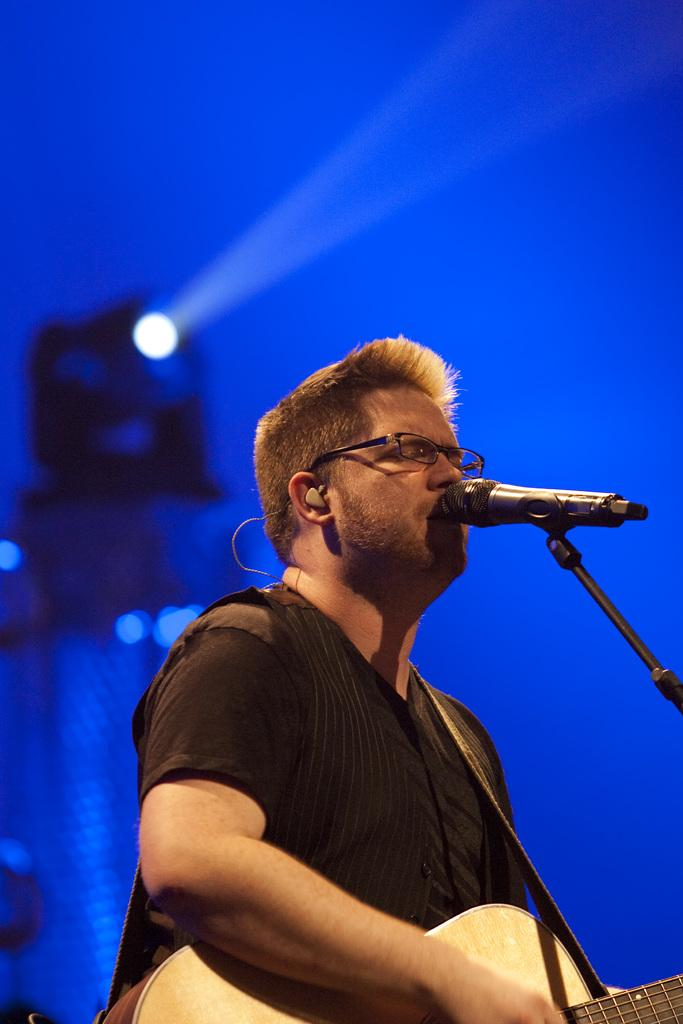What is the man in the image doing? The man is singing a song. What instrument is the man holding in the image? The man is holding a guitar. What device is present for amplifying the man's voice? There is a microphone in the image. How is the microphone positioned in the image? The microphone is on a microphone stand in the image. What is the color of the background in the image? The background of the image has a blue color with a light. Can you see the man's grandmother playing the ring on the can in the image? There is no grandmother, ring, or can present in the image. 